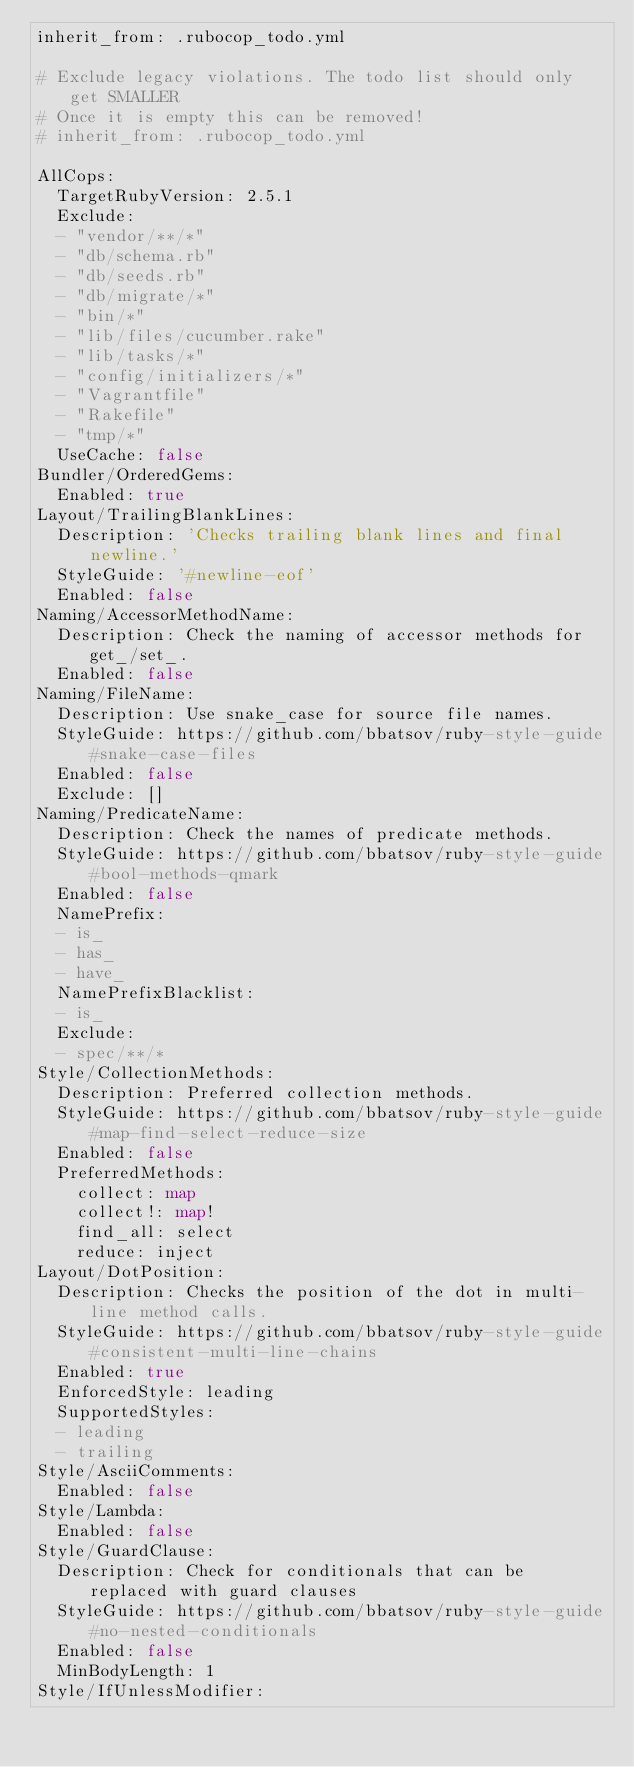Convert code to text. <code><loc_0><loc_0><loc_500><loc_500><_YAML_>inherit_from: .rubocop_todo.yml

# Exclude legacy violations. The todo list should only get SMALLER
# Once it is empty this can be removed!
# inherit_from: .rubocop_todo.yml

AllCops:
  TargetRubyVersion: 2.5.1
  Exclude:
  - "vendor/**/*"
  - "db/schema.rb"
  - "db/seeds.rb"
  - "db/migrate/*"
  - "bin/*"
  - "lib/files/cucumber.rake"
  - "lib/tasks/*"
  - "config/initializers/*"
  - "Vagrantfile"
  - "Rakefile"
  - "tmp/*"
  UseCache: false
Bundler/OrderedGems:
  Enabled: true
Layout/TrailingBlankLines:
  Description: 'Checks trailing blank lines and final newline.'
  StyleGuide: '#newline-eof'
  Enabled: false
Naming/AccessorMethodName:
  Description: Check the naming of accessor methods for get_/set_.
  Enabled: false
Naming/FileName:
  Description: Use snake_case for source file names.
  StyleGuide: https://github.com/bbatsov/ruby-style-guide#snake-case-files
  Enabled: false
  Exclude: []
Naming/PredicateName:
  Description: Check the names of predicate methods.
  StyleGuide: https://github.com/bbatsov/ruby-style-guide#bool-methods-qmark
  Enabled: false
  NamePrefix:
  - is_
  - has_
  - have_
  NamePrefixBlacklist:
  - is_
  Exclude:
  - spec/**/*
Style/CollectionMethods:
  Description: Preferred collection methods.
  StyleGuide: https://github.com/bbatsov/ruby-style-guide#map-find-select-reduce-size
  Enabled: false
  PreferredMethods:
    collect: map
    collect!: map!
    find_all: select
    reduce: inject
Layout/DotPosition:
  Description: Checks the position of the dot in multi-line method calls.
  StyleGuide: https://github.com/bbatsov/ruby-style-guide#consistent-multi-line-chains
  Enabled: true
  EnforcedStyle: leading
  SupportedStyles:
  - leading
  - trailing
Style/AsciiComments:
  Enabled: false
Style/Lambda:
  Enabled: false
Style/GuardClause:
  Description: Check for conditionals that can be replaced with guard clauses
  StyleGuide: https://github.com/bbatsov/ruby-style-guide#no-nested-conditionals
  Enabled: false
  MinBodyLength: 1
Style/IfUnlessModifier:</code> 